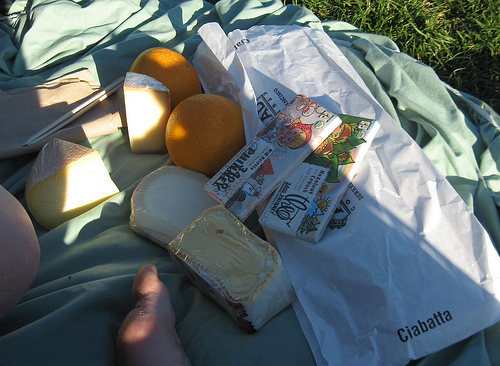<image>
Is there a blanket on the grass? Yes. Looking at the image, I can see the blanket is positioned on top of the grass, with the grass providing support. 